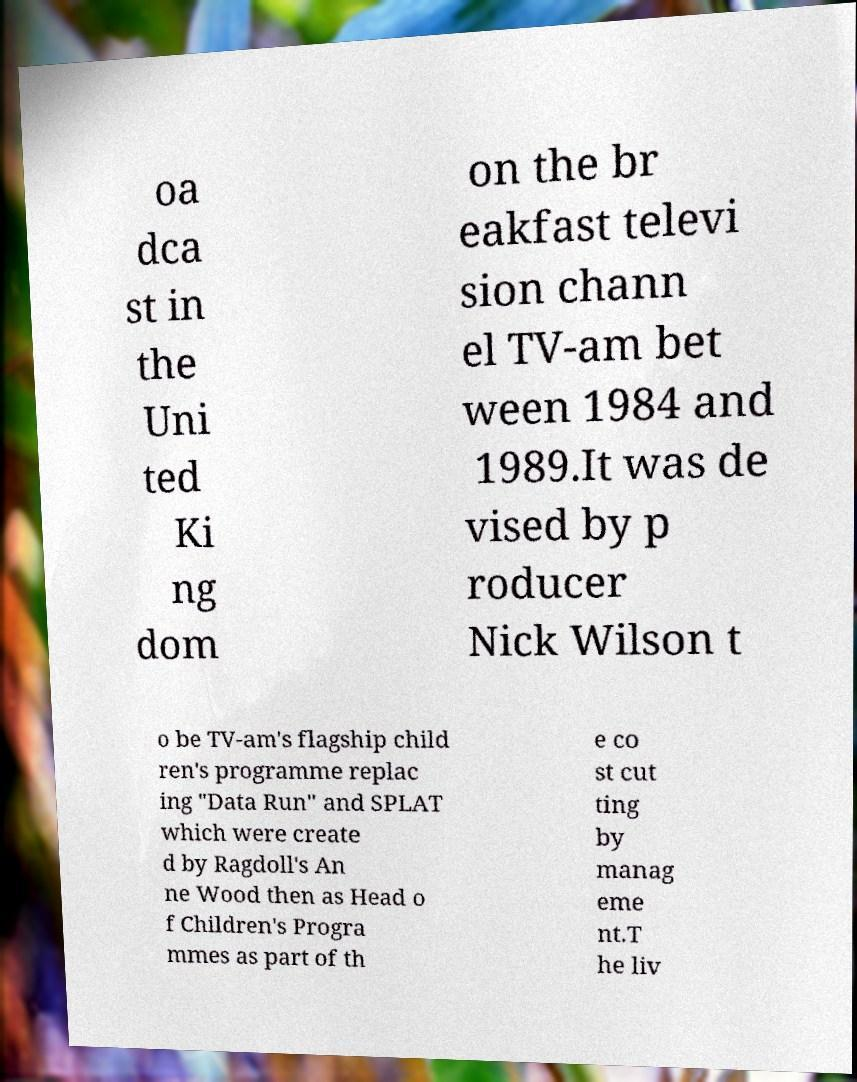Please read and relay the text visible in this image. What does it say? oa dca st in the Uni ted Ki ng dom on the br eakfast televi sion chann el TV-am bet ween 1984 and 1989.It was de vised by p roducer Nick Wilson t o be TV-am's flagship child ren's programme replac ing "Data Run" and SPLAT which were create d by Ragdoll's An ne Wood then as Head o f Children's Progra mmes as part of th e co st cut ting by manag eme nt.T he liv 